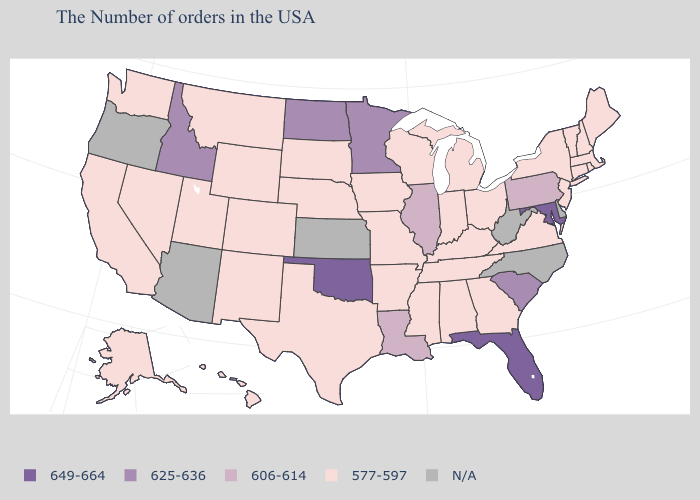Name the states that have a value in the range 625-636?
Keep it brief. South Carolina, Minnesota, North Dakota, Idaho. Name the states that have a value in the range 625-636?
Be succinct. South Carolina, Minnesota, North Dakota, Idaho. Among the states that border Connecticut , which have the highest value?
Keep it brief. Massachusetts, Rhode Island, New York. Name the states that have a value in the range 606-614?
Write a very short answer. Pennsylvania, Illinois, Louisiana. What is the value of Texas?
Concise answer only. 577-597. What is the value of West Virginia?
Quick response, please. N/A. Name the states that have a value in the range 625-636?
Keep it brief. South Carolina, Minnesota, North Dakota, Idaho. Which states hav the highest value in the West?
Answer briefly. Idaho. What is the value of Alabama?
Short answer required. 577-597. Among the states that border Florida , which have the highest value?
Give a very brief answer. Georgia, Alabama. Does Indiana have the highest value in the USA?
Answer briefly. No. Does Florida have the highest value in the USA?
Answer briefly. Yes. Name the states that have a value in the range 606-614?
Write a very short answer. Pennsylvania, Illinois, Louisiana. Which states have the highest value in the USA?
Answer briefly. Maryland, Florida, Oklahoma. 